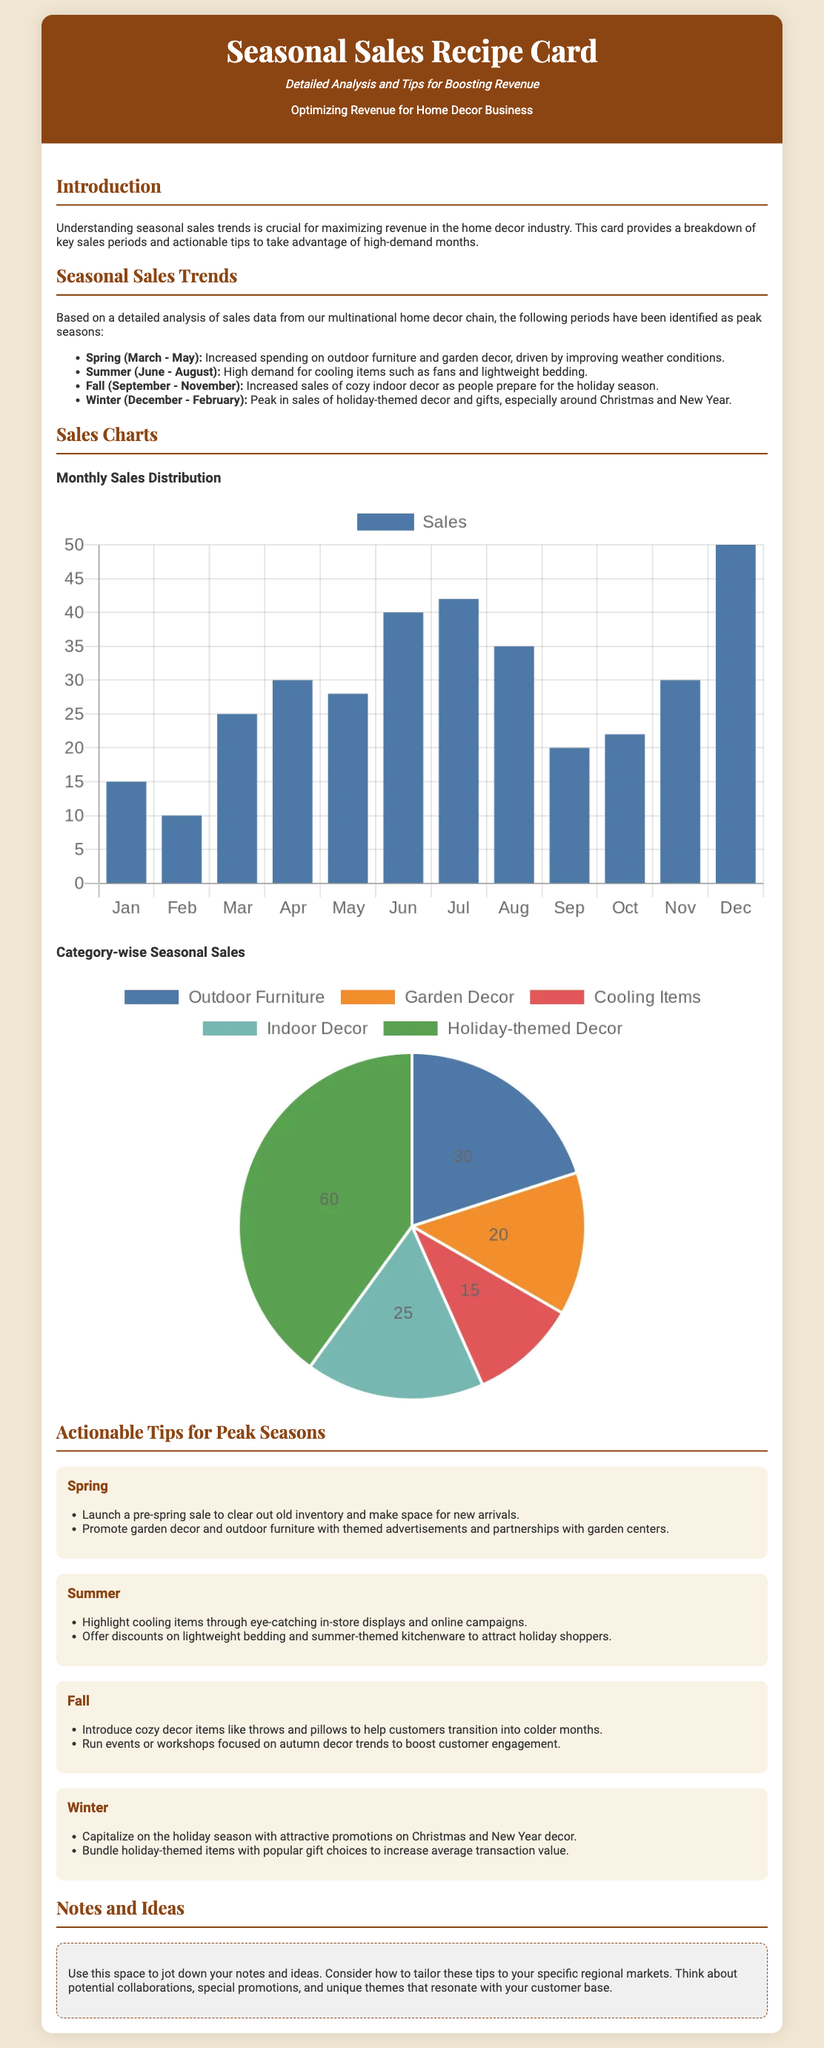what is the subtitle of the card? The subtitle provides additional context for the document's purpose, which is "Detailed Analysis and Tips for Boosting Revenue."
Answer: Detailed Analysis and Tips for Boosting Revenue what are the peak seasons mentioned? The card lists specific months that constitute peak sales periods in the home decor industry.
Answer: Spring, Summer, Fall, Winter which month has the highest sales according to the chart? The card includes a bar chart that visualizes monthly sales data, identifying the month with the highest figure.
Answer: December what type of chart depicts the monthly sales distribution? The document describes the type of visuals used to represent sales data, specifying the format.
Answer: Bar chart what is one actionable tip for the Summer season? The tips section highlights specific strategies tailored to the Summer peak sales period.
Answer: Highlight cooling items what percentage of sales is attributed to Holiday-themed Decor? The pie chart data indicates how much of the total sales come from different categories, including Holiday-themed Decor.
Answer: 60 percent which section provides space for handwritten notes? The layout of the card includes a dedicated section focused on user input rather than predefined content.
Answer: Notes and Ideas how many types of seasonal sales trends are identified? The document organizes information on seasonal sales into distinct categories based on time periods.
Answer: Four categories what color is used for the header background? The color scheme of the document highlights the header area with a specific hue used for design purposes.
Answer: Brown 